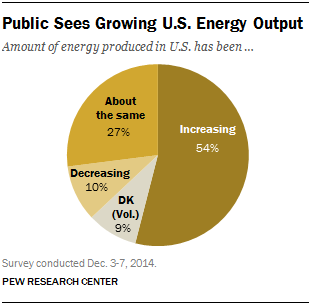Highlight a few significant elements in this photo. I declare that the color of DK is gray. What is the difference in value between decreasing and DK in a pie chart, specifically between 1 and 10? 